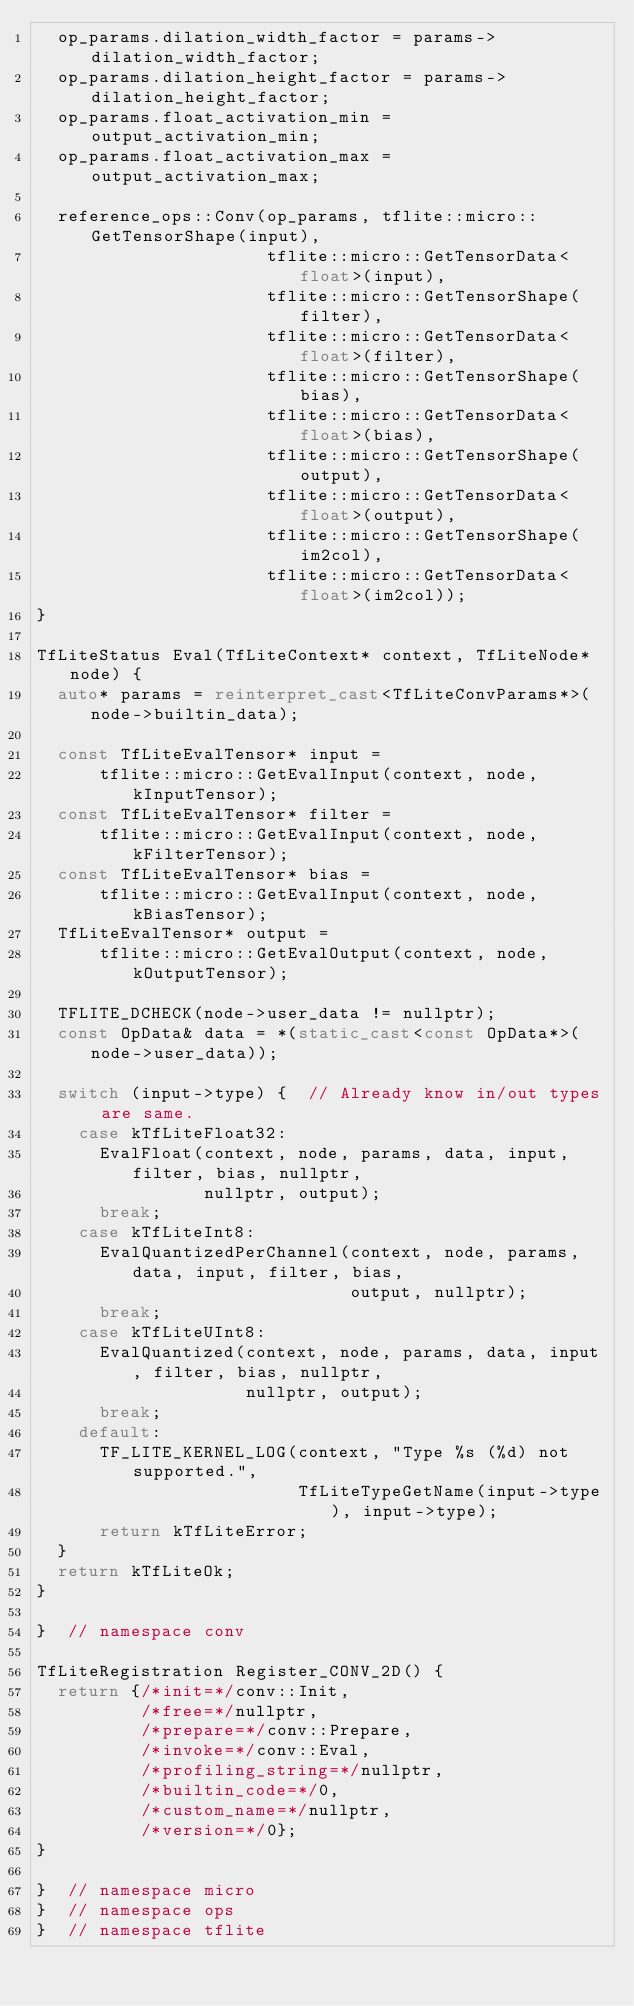<code> <loc_0><loc_0><loc_500><loc_500><_C++_>  op_params.dilation_width_factor = params->dilation_width_factor;
  op_params.dilation_height_factor = params->dilation_height_factor;
  op_params.float_activation_min = output_activation_min;
  op_params.float_activation_max = output_activation_max;

  reference_ops::Conv(op_params, tflite::micro::GetTensorShape(input),
                      tflite::micro::GetTensorData<float>(input),
                      tflite::micro::GetTensorShape(filter),
                      tflite::micro::GetTensorData<float>(filter),
                      tflite::micro::GetTensorShape(bias),
                      tflite::micro::GetTensorData<float>(bias),
                      tflite::micro::GetTensorShape(output),
                      tflite::micro::GetTensorData<float>(output),
                      tflite::micro::GetTensorShape(im2col),
                      tflite::micro::GetTensorData<float>(im2col));
}

TfLiteStatus Eval(TfLiteContext* context, TfLiteNode* node) {
  auto* params = reinterpret_cast<TfLiteConvParams*>(node->builtin_data);

  const TfLiteEvalTensor* input =
      tflite::micro::GetEvalInput(context, node, kInputTensor);
  const TfLiteEvalTensor* filter =
      tflite::micro::GetEvalInput(context, node, kFilterTensor);
  const TfLiteEvalTensor* bias =
      tflite::micro::GetEvalInput(context, node, kBiasTensor);
  TfLiteEvalTensor* output =
      tflite::micro::GetEvalOutput(context, node, kOutputTensor);

  TFLITE_DCHECK(node->user_data != nullptr);
  const OpData& data = *(static_cast<const OpData*>(node->user_data));

  switch (input->type) {  // Already know in/out types are same.
    case kTfLiteFloat32:
      EvalFloat(context, node, params, data, input, filter, bias, nullptr,
                nullptr, output);
      break;
    case kTfLiteInt8:
      EvalQuantizedPerChannel(context, node, params, data, input, filter, bias,
                              output, nullptr);
      break;
    case kTfLiteUInt8:
      EvalQuantized(context, node, params, data, input, filter, bias, nullptr,
                    nullptr, output);
      break;
    default:
      TF_LITE_KERNEL_LOG(context, "Type %s (%d) not supported.",
                         TfLiteTypeGetName(input->type), input->type);
      return kTfLiteError;
  }
  return kTfLiteOk;
}

}  // namespace conv

TfLiteRegistration Register_CONV_2D() {
  return {/*init=*/conv::Init,
          /*free=*/nullptr,
          /*prepare=*/conv::Prepare,
          /*invoke=*/conv::Eval,
          /*profiling_string=*/nullptr,
          /*builtin_code=*/0,
          /*custom_name=*/nullptr,
          /*version=*/0};
}

}  // namespace micro
}  // namespace ops
}  // namespace tflite
</code> 